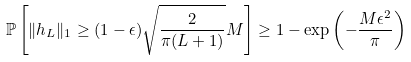<formula> <loc_0><loc_0><loc_500><loc_500>\mathbb { P } \left [ \| { h } _ { L } \| _ { 1 } \geq ( 1 - \epsilon ) \sqrt { \frac { 2 } { \pi ( L + 1 ) } } M \right ] \geq 1 - \exp \left ( - \frac { M \epsilon ^ { 2 } } { \pi } \right )</formula> 